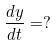Convert formula to latex. <formula><loc_0><loc_0><loc_500><loc_500>\frac { d y } { d t } = ?</formula> 